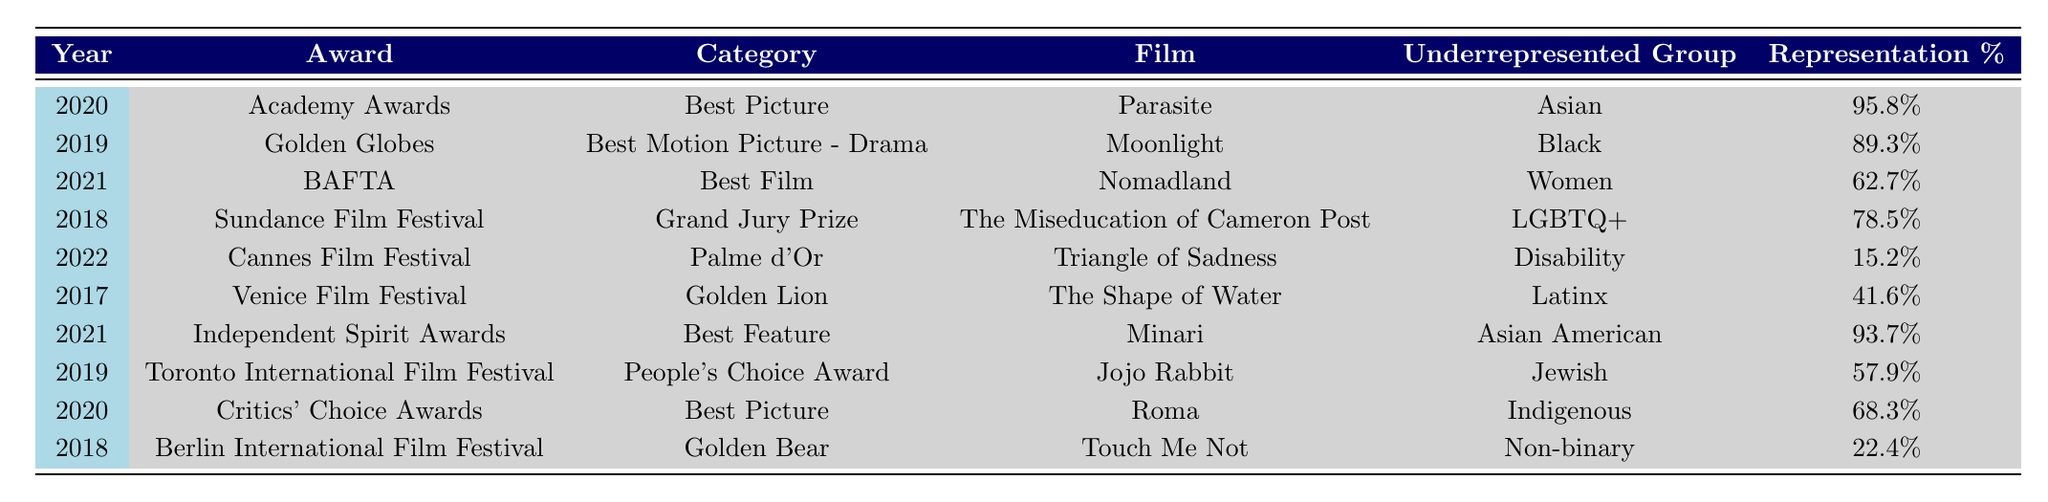What film won the Academy Award for Best Picture in 2020? The table shows that in 2020, "Parasite" won the Academy Award for Best Picture.
Answer: Parasite What percentage of representation does "Moonlight" have for Black individuals? According to the table, "Moonlight" has a representation percentage of 89.3% for Black individuals.
Answer: 89.3% Which film has the lowest representation percentage for its underrepresented group? Checking the representation percentages in the table, "Triangle of Sadness" has the lowest percentage at 15.2%.
Answer: Triangle of Sadness What is the average representation percentage for films featuring Asian individuals? To find the average, add the percentages for "Parasite" (95.8%) and "Minari" (93.7%): 95.8 + 93.7 = 189.5. Then divide by 2: 189.5 / 2 = 94.75.
Answer: 94.75 Did any films feature disabilities as an underrepresented group? Yes, the table indicates that "Triangle of Sadness" featured Disability with a representation percentage of 15.2%.
Answer: Yes What is the difference in representation percentages between "The Shape of Water" and "Moonlight"? "The Shape of Water" has 41.6% and "Moonlight" has 89.3%. The difference is 89.3 - 41.6 = 47.7%.
Answer: 47.7% Which underrepresented group was represented in the most award-winning films on the table? The table lists two films with Asian representation: "Parasite" and "Minari," which is more than any other group.
Answer: Asian Can you identify a film that features women as the underrepresented group and state its representation percentage? "Nomadland" features women as the underrepresented group with a representation percentage of 62.7%.
Answer: 62.7% What award did "The Miseducation of Cameron Post" win? According to the table, "The Miseducation of Cameron Post" won the Grand Jury Prize at the Sundance Film Festival.
Answer: Grand Jury Prize How many films in the table feature underrepresented groups with representation percentages above 80%? The films "Parasite" (95.8%), "Minari" (93.7%), "Moonlight" (89.3%), and "The Miseducation of Cameron Post" (78.5%) have representation percentages above 80%. This totals to four films above the threshold.
Answer: 4 